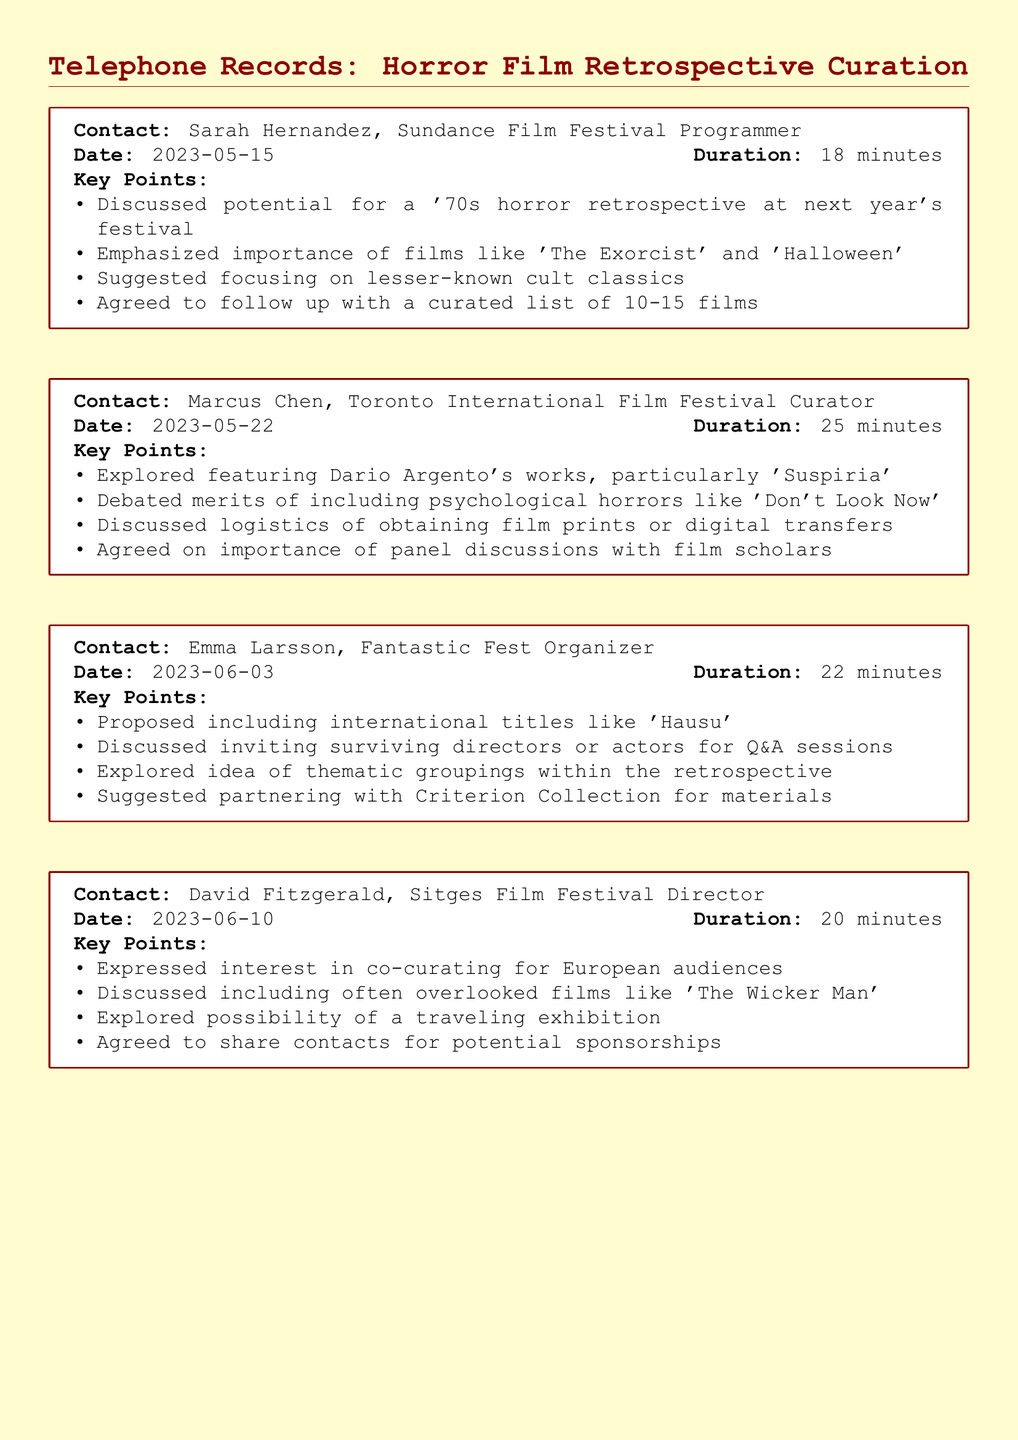What is the date of the call with Sarah Hernandez? The date for the call is mentioned in the document next to her name, which is 2023-05-15.
Answer: 2023-05-15 Who proposed including international titles like 'Hausu'? The document lists Emma Larsson as the contact who proposed this inclusion during the call.
Answer: Emma Larsson How long was the conversation with Marcus Chen? The duration of the call is specified in the document, which is 25 minutes.
Answer: 25 minutes What film was discussed related to Dario Argento? The document states that 'Suspiria' was particularly mentioned in the conversation.
Answer: Suspiria Which film was highlighted as often overlooked by David Fitzgerald? The document indicates that 'The Wicker Man' was discussed as an often overlooked film.
Answer: The Wicker Man What is the purpose of the retrospective according to the conversations? The document expresses that the main focus is on curating innovative horror films from the 1970s.
Answer: Curating innovative horror films from the 1970s How many films are they considering for the curated list? The number is mentioned as a specific range in the discussion with Sarah Hernandez, which is 10-15 films.
Answer: 10-15 films What was a key suggestion made by Emma Larsson? The document mentions her suggestion about inviting surviving directors or actors for Q&A sessions.
Answer: Inviting surviving directors or actors for Q&A sessions What aspect did the curators agree is important for the retrospective? The document emphasizes the importance of panel discussions with film scholars as a significant aspect.
Answer: Panel discussions with film scholars 